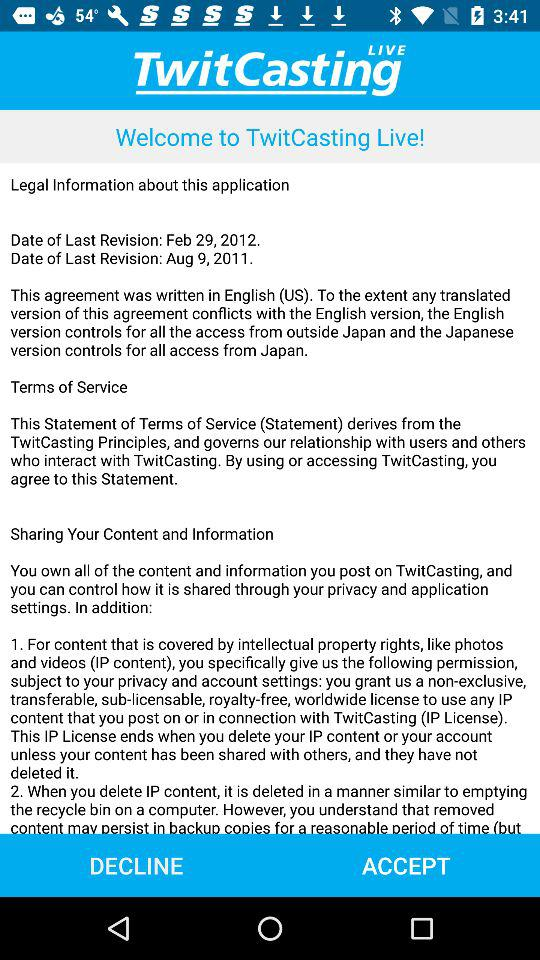What is the mentioned last revision date? The mentioned last revision dates are February 29, 2012, and August 9, 2011. 